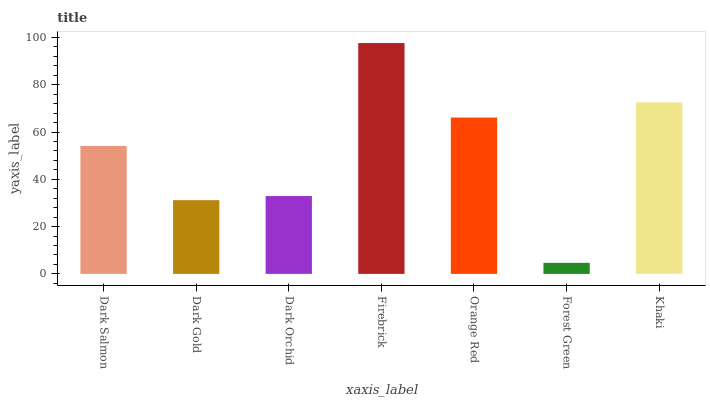Is Forest Green the minimum?
Answer yes or no. Yes. Is Firebrick the maximum?
Answer yes or no. Yes. Is Dark Gold the minimum?
Answer yes or no. No. Is Dark Gold the maximum?
Answer yes or no. No. Is Dark Salmon greater than Dark Gold?
Answer yes or no. Yes. Is Dark Gold less than Dark Salmon?
Answer yes or no. Yes. Is Dark Gold greater than Dark Salmon?
Answer yes or no. No. Is Dark Salmon less than Dark Gold?
Answer yes or no. No. Is Dark Salmon the high median?
Answer yes or no. Yes. Is Dark Salmon the low median?
Answer yes or no. Yes. Is Dark Orchid the high median?
Answer yes or no. No. Is Khaki the low median?
Answer yes or no. No. 